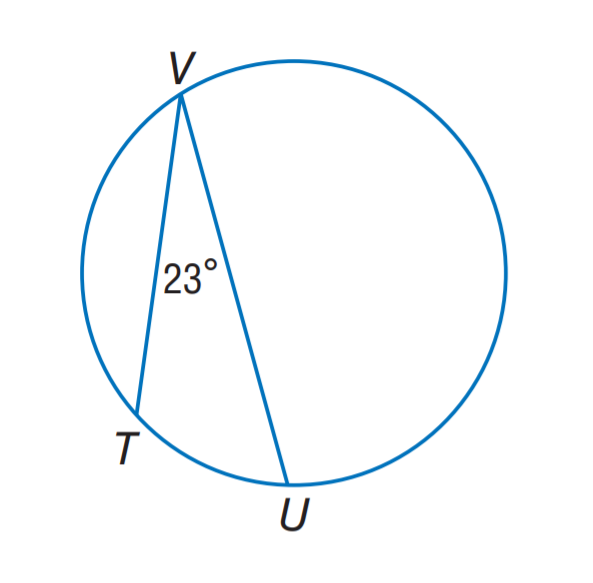Answer the mathemtical geometry problem and directly provide the correct option letter.
Question: Find m \widehat T U.
Choices: A: 11.5 B: 23 C: 46 D: 67 C 